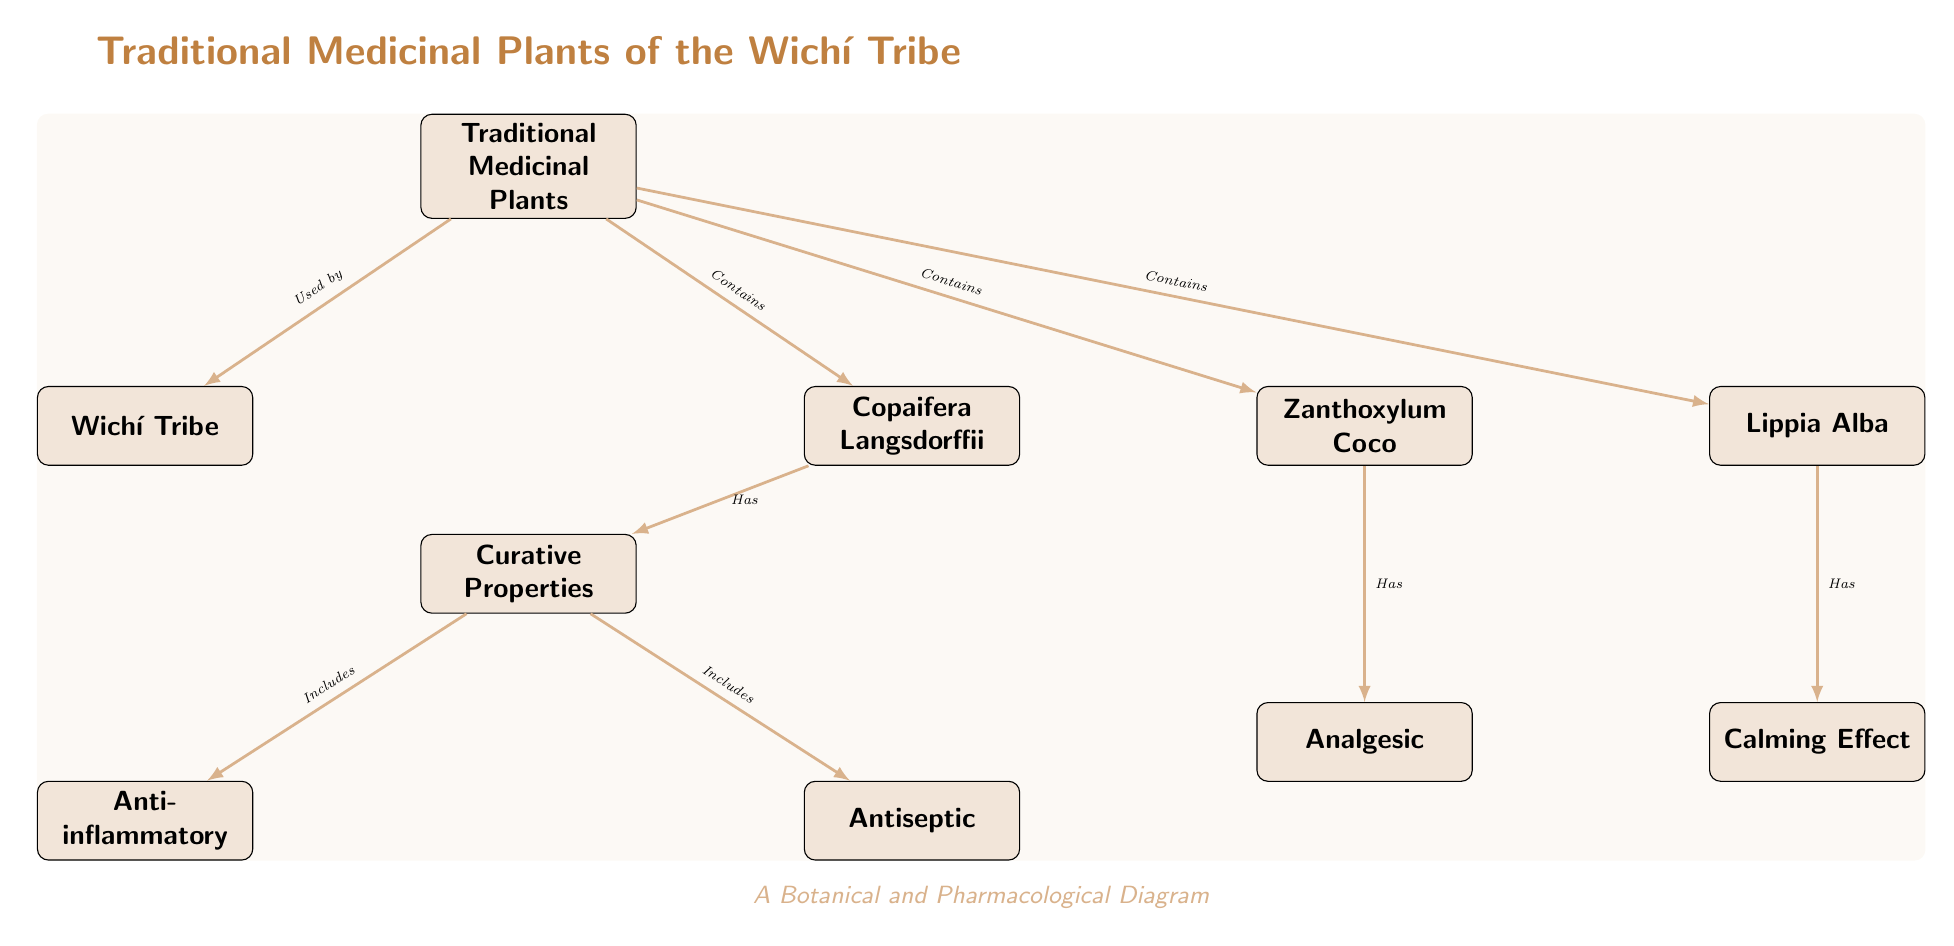What is the title of the diagram? The title is mentioned at the top, specifically labeled as "Traditional Medicinal Plants of the Wichí Tribe."
Answer: Traditional Medicinal Plants of the Wichí Tribe How many traditional medicinal plants are highlighted in the diagram? The diagram lists three specific traditional medicinal plants: Copaifera Langsdorffii, Zanthoxylum Coco, and Lippia Alba, adding up to a total of three.
Answer: 3 What curative property is associated with Copaifera Langsdorffii? Copaifera Langsdorffii is linked to the "Curative Properties" node, indicating it "Has" "Anti-inflammatory" properties.
Answer: Anti-inflammatory What relationship do the Wichí Tribe have with traditional medicinal plants? The Wichí Tribe is connected to the central node labeled "Traditional Medicinal Plants," indicating they are "Used by" the tribe.
Answer: Used by What calming effect is attributed to Lippia Alba in the diagram? Lippia Alba is shown to have a specific curative property labeled "Calming Effect," which is mentioned in the node directly below it.
Answer: Calming Effect Which plant is associated with an analgesic property? The plant Zanthoxylum Coco is connected to the "Has" node for "Analgesic," hence it has this curative property.
Answer: Zanthoxylum Coco Which traditional medicinal plant has antiseptic properties? The "Antiseptic" property is indicated to come from the node "Curative Properties," which links to Copaifera Langsdorffii.
Answer: Copaifera Langsdorffii What are the curative properties listed in the diagram? The curative properties outlined in the diagram are "Anti-inflammatory" and "Antiseptic," for Copaifera Langsdorffii, and "Analgesic" and "Calming Effect" for Zanthoxylum Coco and Lippia Alba, respectively.
Answer: Anti-inflammatory, Antiseptic, Analgesic, Calming Effect How many curative properties are listed in the diagram? The diagram specifies four distinct curative properties for the medicinal plants included: Anti-inflammatory, Antiseptic, Analgesic, and Calming Effect, hence totaling four.
Answer: 4 